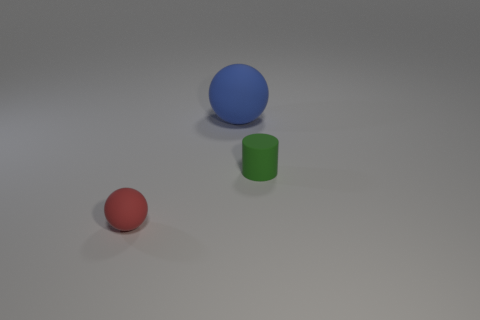Is there a small shiny cube of the same color as the cylinder?
Your answer should be very brief. No. Are there fewer tiny blue metal things than blue balls?
Provide a succinct answer. Yes. How many things are big purple matte objects or things right of the red rubber thing?
Your response must be concise. 2. Is there another large red cylinder that has the same material as the cylinder?
Your answer should be compact. No. There is a red sphere that is the same size as the rubber cylinder; what is its material?
Offer a terse response. Rubber. The ball in front of the matte object that is to the right of the blue object is made of what material?
Make the answer very short. Rubber. Is the shape of the thing to the right of the blue sphere the same as  the blue thing?
Offer a terse response. No. What is the color of the small sphere that is made of the same material as the big blue ball?
Offer a terse response. Red. What is the material of the ball that is in front of the green matte cylinder?
Provide a succinct answer. Rubber. Does the tiny green thing have the same shape as the small matte thing that is in front of the tiny green rubber cylinder?
Your answer should be very brief. No. 